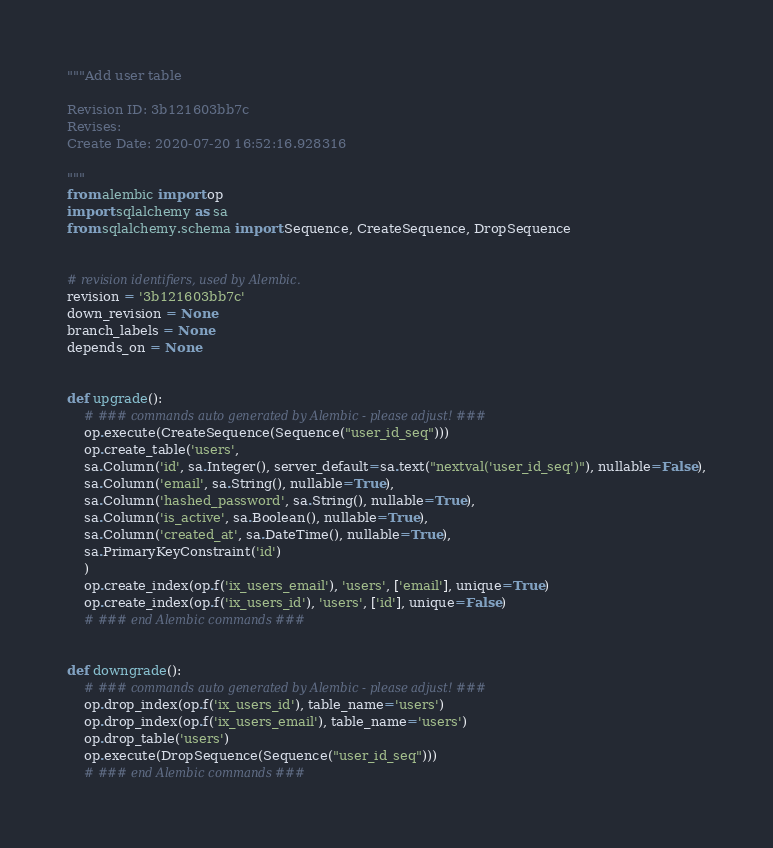<code> <loc_0><loc_0><loc_500><loc_500><_Python_>"""Add user table

Revision ID: 3b121603bb7c
Revises: 
Create Date: 2020-07-20 16:52:16.928316

"""
from alembic import op
import sqlalchemy as sa
from sqlalchemy.schema import Sequence, CreateSequence, DropSequence


# revision identifiers, used by Alembic.
revision = '3b121603bb7c'
down_revision = None
branch_labels = None
depends_on = None


def upgrade():
    # ### commands auto generated by Alembic - please adjust! ###
    op.execute(CreateSequence(Sequence("user_id_seq")))
    op.create_table('users',
    sa.Column('id', sa.Integer(), server_default=sa.text("nextval('user_id_seq')"), nullable=False),
    sa.Column('email', sa.String(), nullable=True),
    sa.Column('hashed_password', sa.String(), nullable=True),
    sa.Column('is_active', sa.Boolean(), nullable=True),
    sa.Column('created_at', sa.DateTime(), nullable=True),
    sa.PrimaryKeyConstraint('id')
    )
    op.create_index(op.f('ix_users_email'), 'users', ['email'], unique=True)
    op.create_index(op.f('ix_users_id'), 'users', ['id'], unique=False)
    # ### end Alembic commands ###


def downgrade():
    # ### commands auto generated by Alembic - please adjust! ###
    op.drop_index(op.f('ix_users_id'), table_name='users')
    op.drop_index(op.f('ix_users_email'), table_name='users')
    op.drop_table('users')
    op.execute(DropSequence(Sequence("user_id_seq")))
    # ### end Alembic commands ###
</code> 